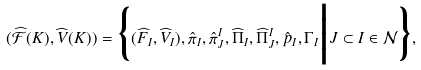Convert formula to latex. <formula><loc_0><loc_0><loc_500><loc_500>( \widehat { \mathcal { F } } ( K ) , { \widehat { V } } ( K ) ) = \Big \{ ( \widehat { F } _ { I } , \widehat { V } _ { I } ) , \hat { \pi } _ { I } , \hat { \pi } ^ { I } _ { J } , \widehat { \Pi } _ { I } , \widehat { \Pi } ^ { I } _ { J } , \hat { p } _ { I } , \Gamma _ { I } \Big | J \subset I \in { \mathcal { N } } \Big \} ,</formula> 